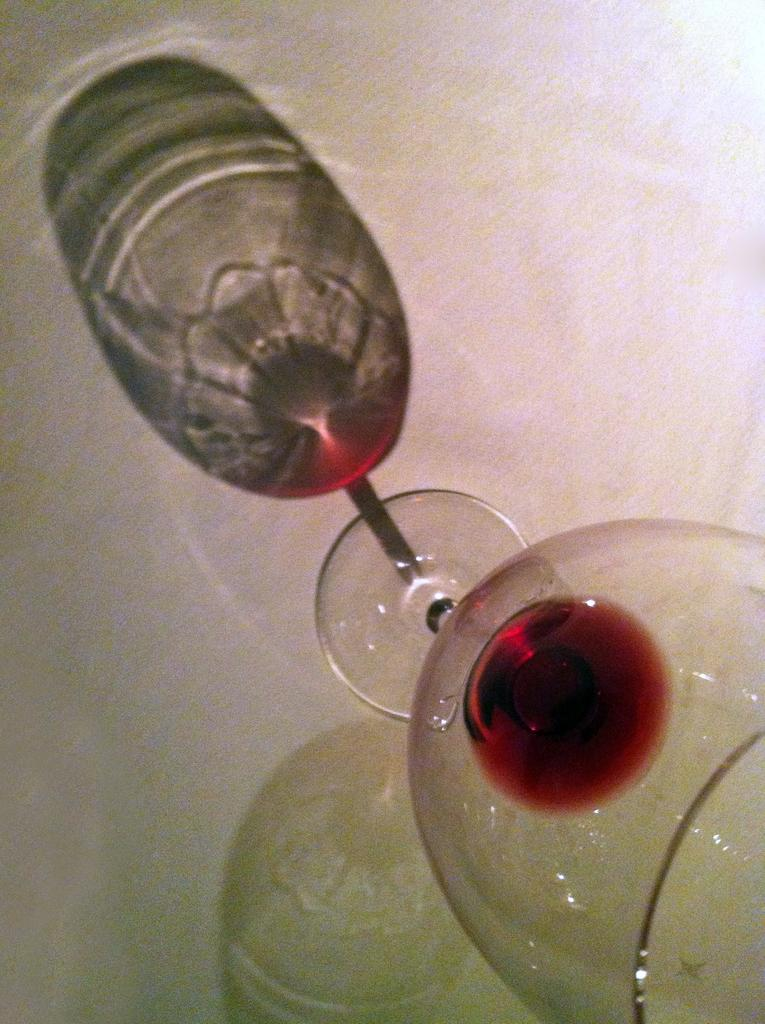What can be seen in the image that casts a shadow? There are shadows of a glass in the image. What is inside the glass that casts the shadow? The glass contains a drink. Can you see a worm crawling on the rim of the glass in the image? No, there is no worm present in the image. 